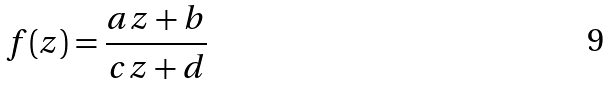<formula> <loc_0><loc_0><loc_500><loc_500>f ( z ) = { \frac { a z + b } { c z + d } }</formula> 